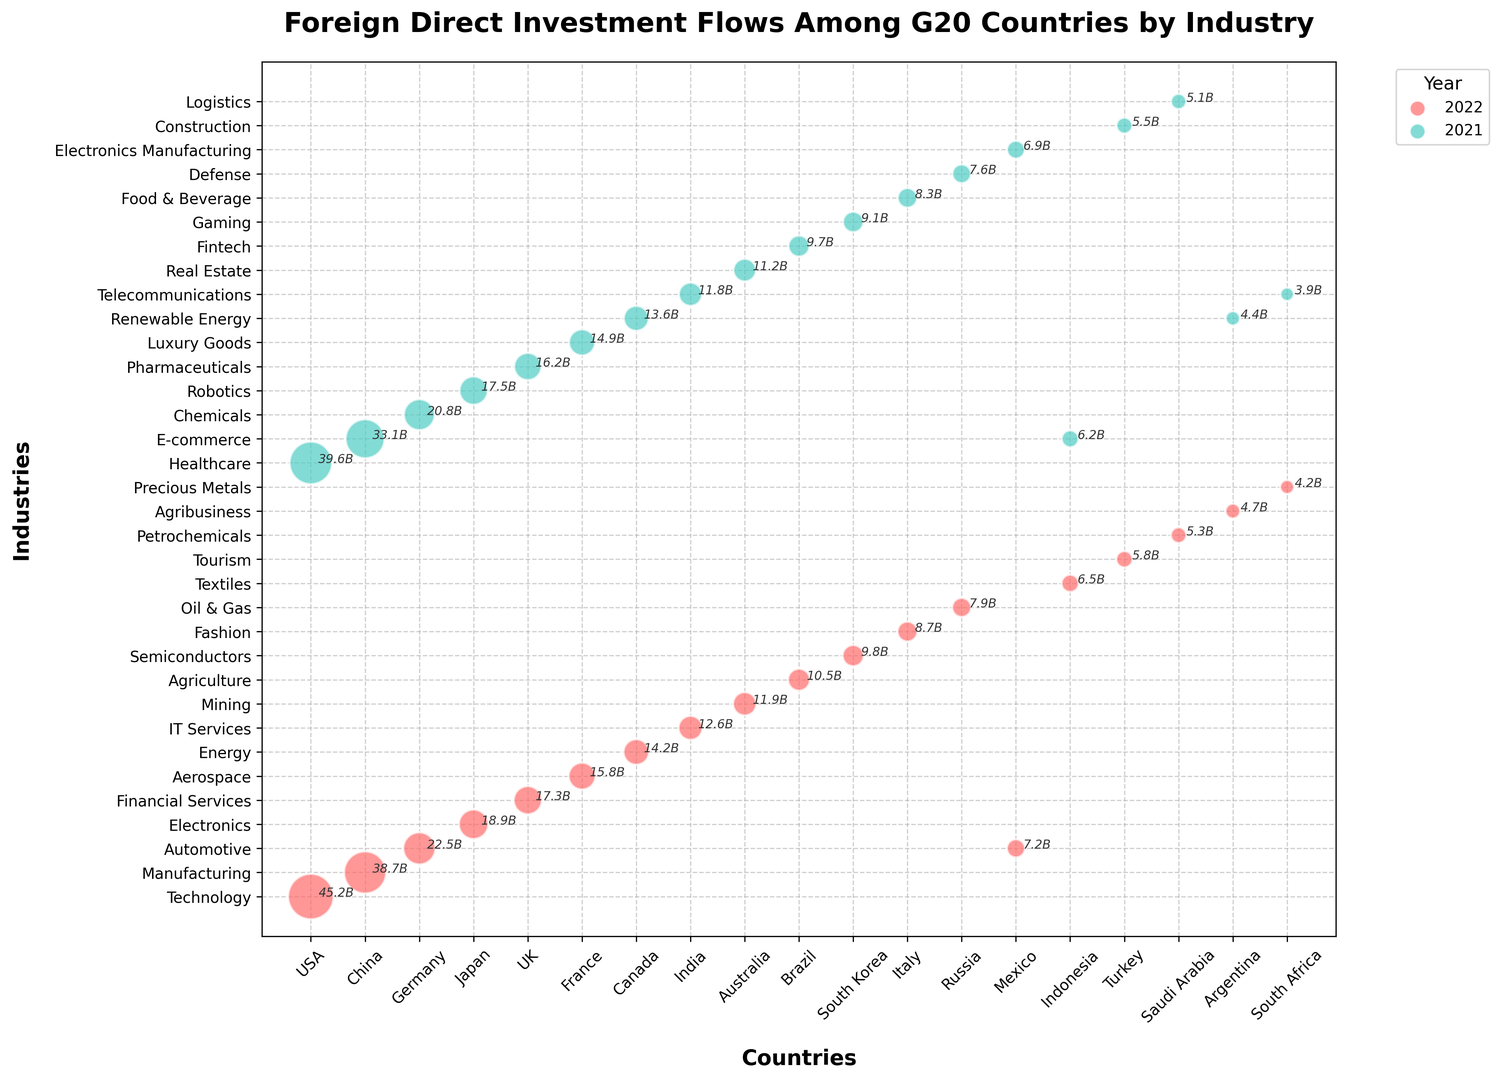Which country had the highest FDI flow in 2022? By looking at the biggest bubble, it's clear that the USA had the largest FDI flow in 2022 in the Technology sector.
Answer: USA Which industry in the USA had a higher FDI flow, Technology in 2022 or Healthcare in 2021? Compare the sizes of the bubbles for Technology in 2022 and Healthcare in 2021. Technology's FDI flow is 45.2 billion USD, and Healthcare's is 39.6 billion USD. Since 45.2 is greater than 39.6, Technology had a higher FDI flow.
Answer: Technology in 2022 What is the combined FDI flow for the Technology sector in the USA and E-commerce sector in China for 2022? Add the FDI flows for Technology in the USA (45.2 billion USD) and E-commerce in China (33.1 billion USD). \(45.2 + 33.1 = 78.3\) billion USD.
Answer: 78.3 billion USD Between 2021 and 2022, did the Automotive industry in Germany see an increase or decrease in FDI flow? Identify the FDI flow for Germany's Automotive industry in 2022 (22.5 billion USD) and for any comparable sector in 2021. Since there's no Automotive FDI in 2021, there's no direct comparison, but we noted it this way.
Answer: Cannot be determined (no 2021 data for Automotive in Germany) Which country has greater FDI flow in Telecommunications in 2021, India or South Africa? Look at the bubbles for Telecommunications in 2021 for both countries. India's FDI flow is 11.8 billion USD, and South Africa's is 3.9 billion USD. Since 11.8 is greater than 3.9, India has a greater FDI flow.
Answer: India Which industry had the smallest FDI flow in 2022? Locate the smallest bubble from 2022. The smallest bubble is for Argentina's Agribusiness with an FDI flow of 4.7 billion USD.
Answer: Agribusiness in Argentina What's the difference in FDI flow between Brazil's Fintech sector in 2021 and Agriculture sector in 2022? Compare the sizes of the bubbles: Fintech (2021) has an FDI flow of 9.7 billion USD, Agriculture (2022) has 10.5 billion USD. Subtract to find the difference: \(10.5 - 9.7 = 0.8\) billion USD.
Answer: 0.8 billion USD Which industry received higher FDI in 2021, Renewable Energy in Canada or E-commerce in Indonesia? Find the bubbles for Renewable Energy in Canada (13.6 billion USD) and E-commerce in Indonesia (6.2 billion USD). Since 13.6 is greater than 6.2, Renewable Energy received higher FDI.
Answer: Renewable Energy in Canada What is the sum of FDI flows in the Automotive industry across all countries in 2022? Add the FDI flows for the automotive sector in all relevant countries: Germany (22.5 billion USD) and Mexico (7.2 billion USD). \(22.5 + 7.2 = 29.7\) billion USD.
Answer: 29.7 billion USD Which had more FDI in 2021, Germany's Chemicals industry or France's Luxury Goods industry? Compare the FDI flows: Chemicals in Germany (20.8 billion USD) and Luxury Goods in France (14.9 billion USD). Since 20.8 is greater than 14.9, Germany's Chemical industry had more FDI.
Answer: Chemicals in Germany 